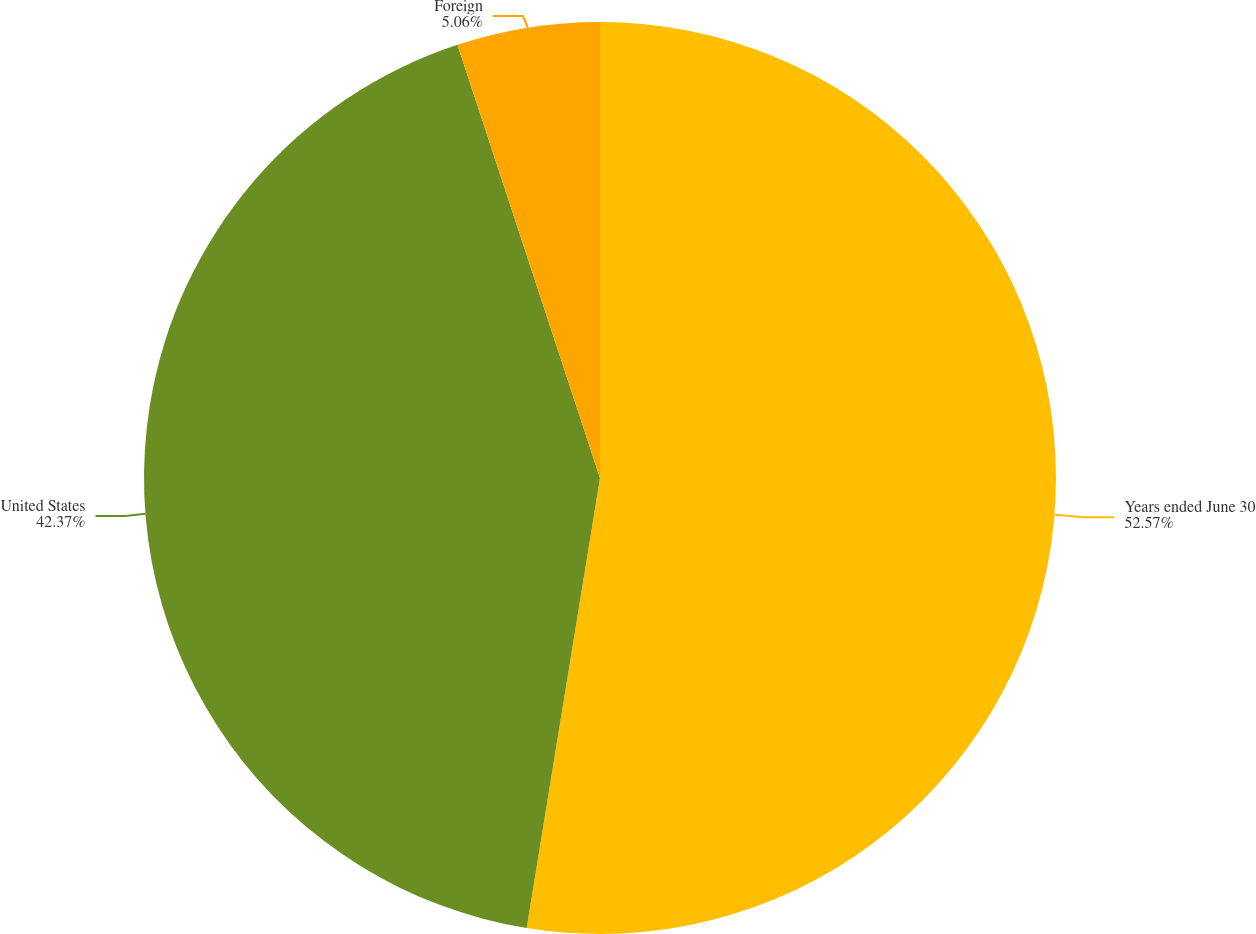Convert chart. <chart><loc_0><loc_0><loc_500><loc_500><pie_chart><fcel>Years ended June 30<fcel>United States<fcel>Foreign<nl><fcel>52.57%<fcel>42.37%<fcel>5.06%<nl></chart> 